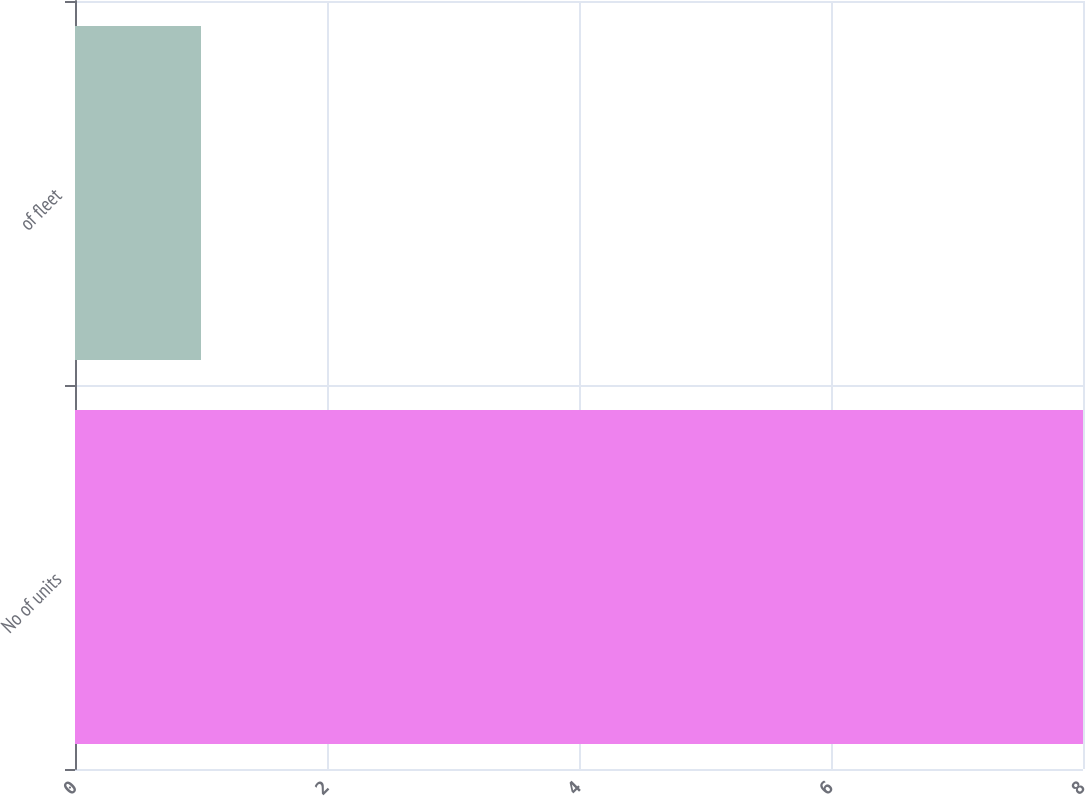Convert chart. <chart><loc_0><loc_0><loc_500><loc_500><bar_chart><fcel>No of units<fcel>of fleet<nl><fcel>8<fcel>1<nl></chart> 